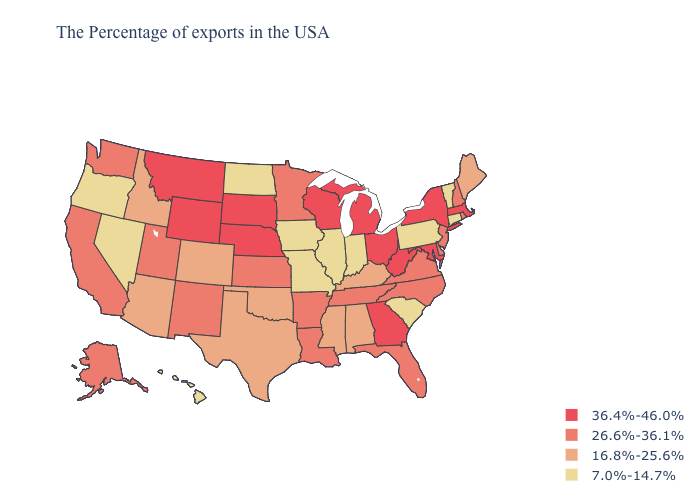Does Arkansas have the same value as Oklahoma?
Concise answer only. No. Name the states that have a value in the range 16.8%-25.6%?
Be succinct. Maine, Kentucky, Alabama, Mississippi, Oklahoma, Texas, Colorado, Arizona, Idaho. Does Nebraska have the lowest value in the USA?
Keep it brief. No. What is the value of Alaska?
Keep it brief. 26.6%-36.1%. Name the states that have a value in the range 16.8%-25.6%?
Write a very short answer. Maine, Kentucky, Alabama, Mississippi, Oklahoma, Texas, Colorado, Arizona, Idaho. Which states have the lowest value in the West?
Keep it brief. Nevada, Oregon, Hawaii. What is the value of Hawaii?
Write a very short answer. 7.0%-14.7%. Does Nevada have the lowest value in the West?
Answer briefly. Yes. What is the value of Kansas?
Write a very short answer. 26.6%-36.1%. What is the value of Maryland?
Give a very brief answer. 36.4%-46.0%. Does Michigan have a higher value than Hawaii?
Give a very brief answer. Yes. What is the highest value in states that border South Dakota?
Be succinct. 36.4%-46.0%. What is the value of Louisiana?
Short answer required. 26.6%-36.1%. Does New Jersey have a higher value than Hawaii?
Write a very short answer. Yes. What is the value of Texas?
Answer briefly. 16.8%-25.6%. 